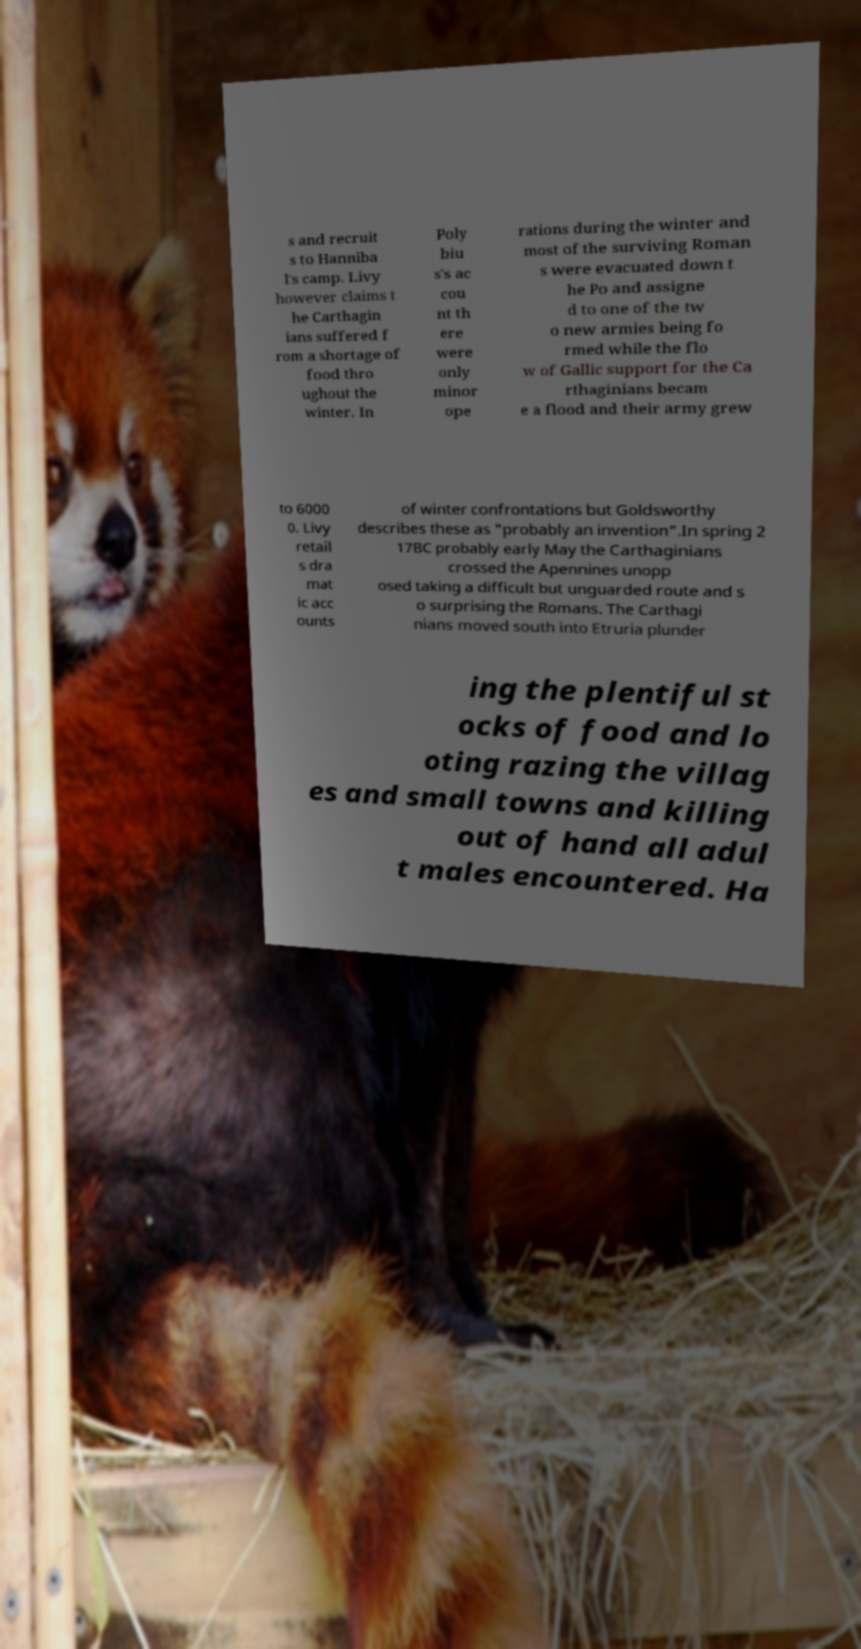Could you extract and type out the text from this image? s and recruit s to Hanniba l's camp. Livy however claims t he Carthagin ians suffered f rom a shortage of food thro ughout the winter. In Poly biu s's ac cou nt th ere were only minor ope rations during the winter and most of the surviving Roman s were evacuated down t he Po and assigne d to one of the tw o new armies being fo rmed while the flo w of Gallic support for the Ca rthaginians becam e a flood and their army grew to 6000 0. Livy retail s dra mat ic acc ounts of winter confrontations but Goldsworthy describes these as "probably an invention".In spring 2 17BC probably early May the Carthaginians crossed the Apennines unopp osed taking a difficult but unguarded route and s o surprising the Romans. The Carthagi nians moved south into Etruria plunder ing the plentiful st ocks of food and lo oting razing the villag es and small towns and killing out of hand all adul t males encountered. Ha 